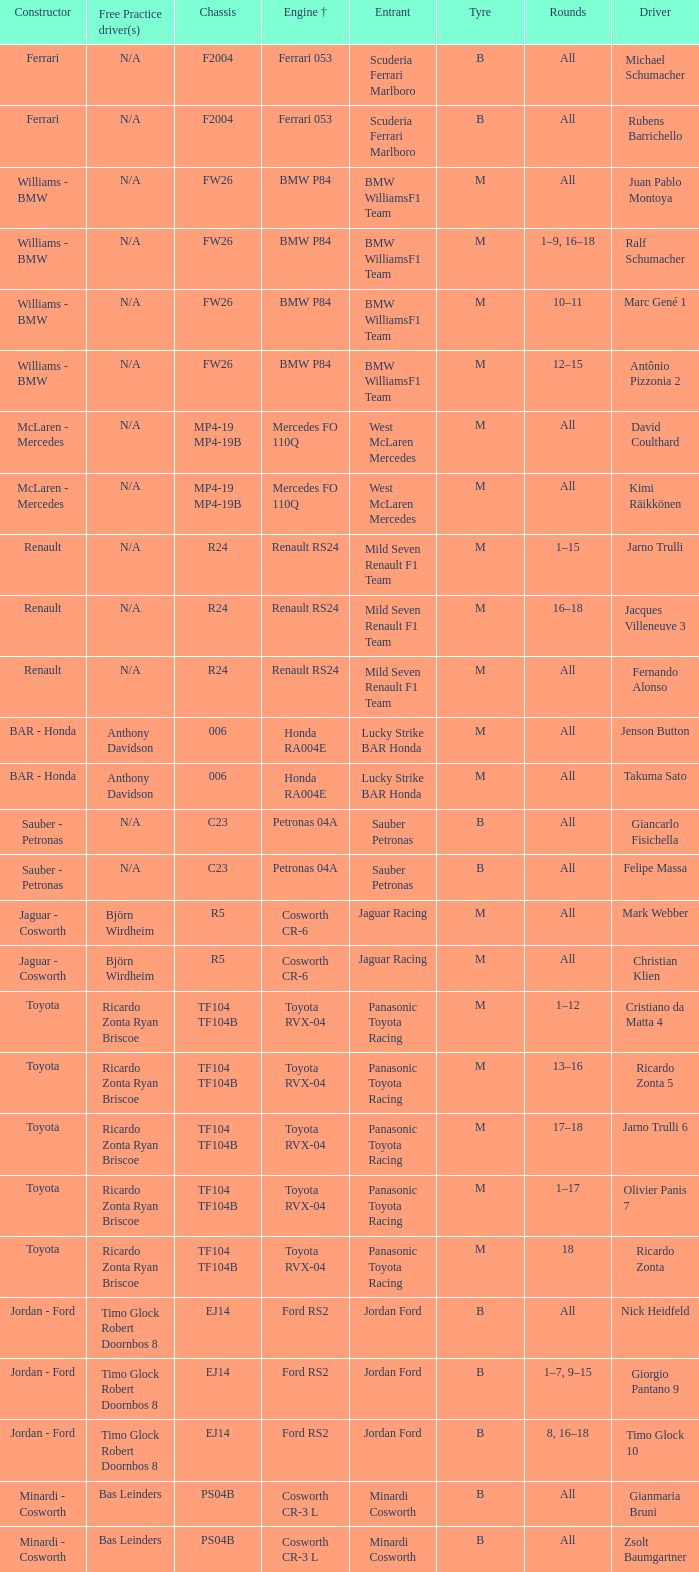What kind of free practice is there with a Ford RS2 engine +? Timo Glock Robert Doornbos 8, Timo Glock Robert Doornbos 8, Timo Glock Robert Doornbos 8. 